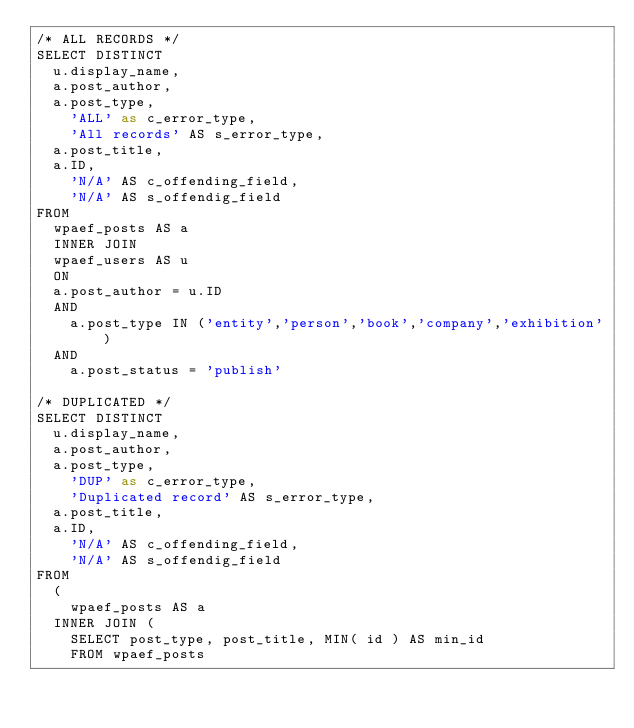<code> <loc_0><loc_0><loc_500><loc_500><_SQL_>/* ALL RECORDS */
SELECT DISTINCT
	u.display_name,
	a.post_author, 
	a.post_type,
    'ALL' as c_error_type, 
    'All records' AS s_error_type,
	a.post_title,
	a.ID,
    'N/A' AS c_offending_field,
    'N/A' AS s_offendig_field
FROM 
	wpaef_posts AS a
	INNER JOIN
	wpaef_users AS u
	ON
	a.post_author = u.ID
	AND 
    a.post_type IN ('entity','person','book','company','exhibition') 
	AND 
    a.post_status = 'publish'

/* DUPLICATED */
SELECT DISTINCT
	u.display_name,
	a.post_author, 
	a.post_type,
    'DUP' as c_error_type, 
    'Duplicated record' AS s_error_type,
	a.post_title,
	a.ID,
    'N/A' AS c_offending_field,
    'N/A' AS s_offendig_field
FROM 
	(
    wpaef_posts AS a
	INNER JOIN (
		SELECT post_type, post_title, MIN( id ) AS min_id
		FROM wpaef_posts</code> 